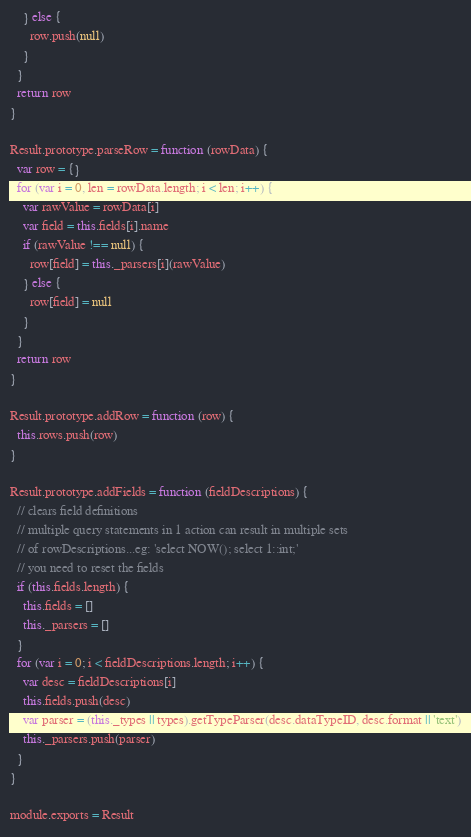Convert code to text. <code><loc_0><loc_0><loc_500><loc_500><_JavaScript_>    } else {
      row.push(null)
    }
  }
  return row
}

Result.prototype.parseRow = function (rowData) {
  var row = {}
  for (var i = 0, len = rowData.length; i < len; i++) {
    var rawValue = rowData[i]
    var field = this.fields[i].name
    if (rawValue !== null) {
      row[field] = this._parsers[i](rawValue)
    } else {
      row[field] = null
    }
  }
  return row
}

Result.prototype.addRow = function (row) {
  this.rows.push(row)
}

Result.prototype.addFields = function (fieldDescriptions) {
  // clears field definitions
  // multiple query statements in 1 action can result in multiple sets
  // of rowDescriptions...eg: 'select NOW(); select 1::int;'
  // you need to reset the fields
  if (this.fields.length) {
    this.fields = []
    this._parsers = []
  }
  for (var i = 0; i < fieldDescriptions.length; i++) {
    var desc = fieldDescriptions[i]
    this.fields.push(desc)
    var parser = (this._types || types).getTypeParser(desc.dataTypeID, desc.format || 'text')
    this._parsers.push(parser)
  }
}

module.exports = Result
</code> 